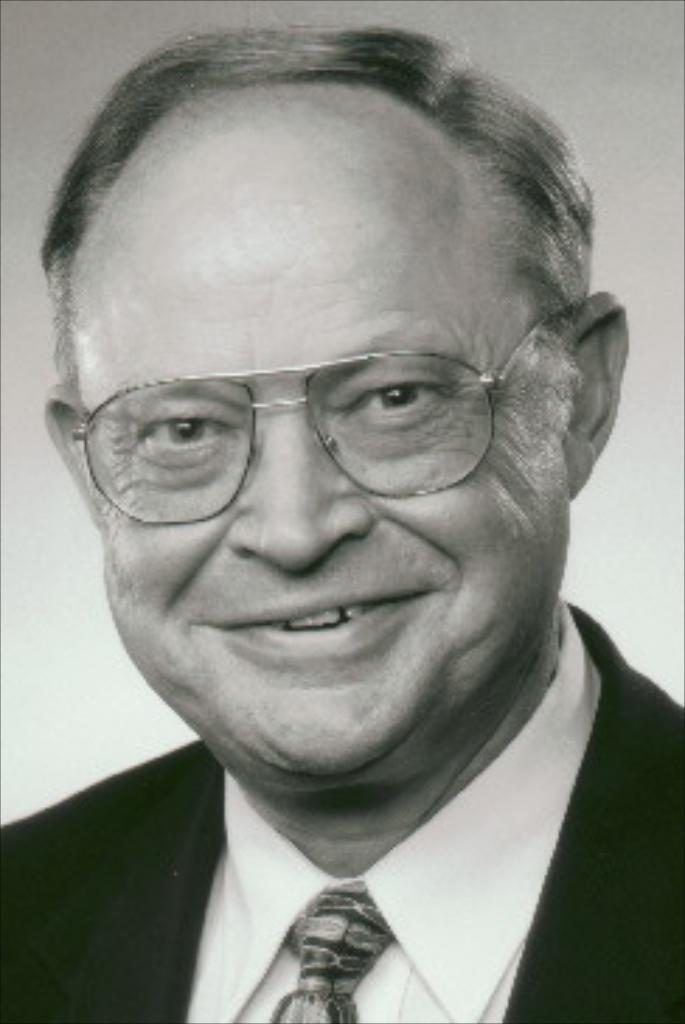What is the color scheme of the image? The image is black and white. Can you describe the person in the image? There is a man in the image. What accessory is the man wearing? The man is wearing specs. What type of lace can be seen on the man's clothing in the image? There is no lace visible on the man's clothing in the image, as it is a black and white image and the man is wearing specs. 